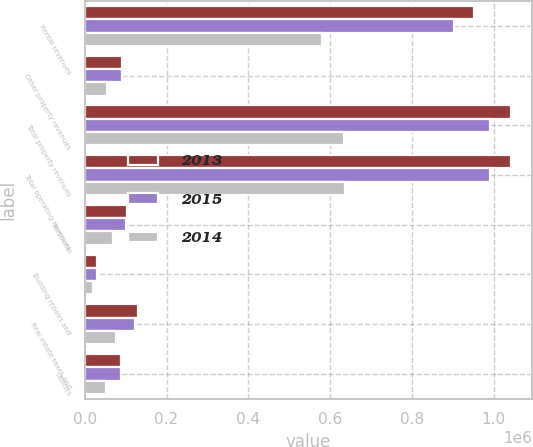<chart> <loc_0><loc_0><loc_500><loc_500><stacked_bar_chart><ecel><fcel>Rental revenues<fcel>Other property revenues<fcel>Total property revenues<fcel>Total operating revenues<fcel>Personnel<fcel>Building repairs and<fcel>Real estate taxes and<fcel>Utilities<nl><fcel>2013<fcel>952196<fcel>90583<fcel>1.04278e+06<fcel>1.04278e+06<fcel>103000<fcel>30524<fcel>129618<fcel>89769<nl><fcel>2015<fcel>902177<fcel>90001<fcel>992178<fcel>992332<fcel>101591<fcel>30715<fcel>123419<fcel>89150<nl><fcel>2014<fcel>580963<fcel>53880<fcel>634843<fcel>635490<fcel>68299<fcel>20308<fcel>76922<fcel>51737<nl></chart> 